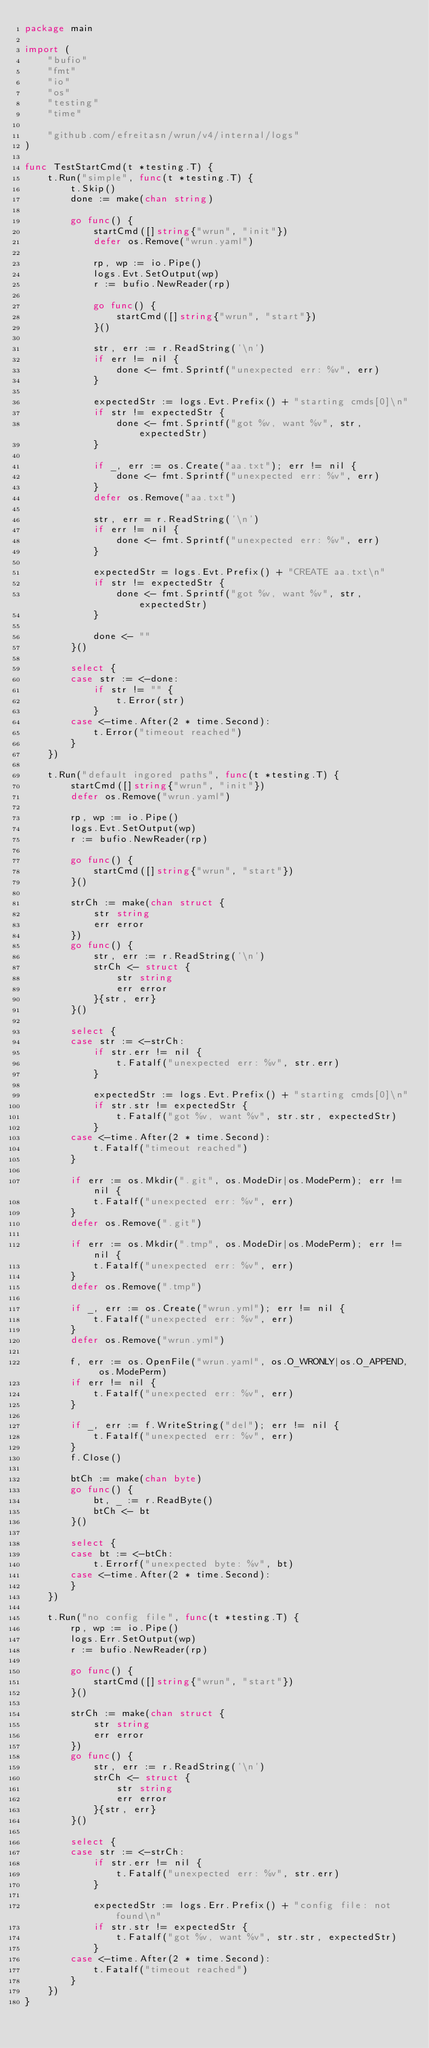<code> <loc_0><loc_0><loc_500><loc_500><_Go_>package main

import (
	"bufio"
	"fmt"
	"io"
	"os"
	"testing"
	"time"

	"github.com/efreitasn/wrun/v4/internal/logs"
)

func TestStartCmd(t *testing.T) {
	t.Run("simple", func(t *testing.T) {
		t.Skip()
		done := make(chan string)

		go func() {
			startCmd([]string{"wrun", "init"})
			defer os.Remove("wrun.yaml")

			rp, wp := io.Pipe()
			logs.Evt.SetOutput(wp)
			r := bufio.NewReader(rp)

			go func() {
				startCmd([]string{"wrun", "start"})
			}()

			str, err := r.ReadString('\n')
			if err != nil {
				done <- fmt.Sprintf("unexpected err: %v", err)
			}

			expectedStr := logs.Evt.Prefix() + "starting cmds[0]\n"
			if str != expectedStr {
				done <- fmt.Sprintf("got %v, want %v", str, expectedStr)
			}

			if _, err := os.Create("aa.txt"); err != nil {
				done <- fmt.Sprintf("unexpected err: %v", err)
			}
			defer os.Remove("aa.txt")

			str, err = r.ReadString('\n')
			if err != nil {
				done <- fmt.Sprintf("unexpected err: %v", err)
			}

			expectedStr = logs.Evt.Prefix() + "CREATE aa.txt\n"
			if str != expectedStr {
				done <- fmt.Sprintf("got %v, want %v", str, expectedStr)
			}

			done <- ""
		}()

		select {
		case str := <-done:
			if str != "" {
				t.Error(str)
			}
		case <-time.After(2 * time.Second):
			t.Error("timeout reached")
		}
	})

	t.Run("default ingored paths", func(t *testing.T) {
		startCmd([]string{"wrun", "init"})
		defer os.Remove("wrun.yaml")

		rp, wp := io.Pipe()
		logs.Evt.SetOutput(wp)
		r := bufio.NewReader(rp)

		go func() {
			startCmd([]string{"wrun", "start"})
		}()

		strCh := make(chan struct {
			str string
			err error
		})
		go func() {
			str, err := r.ReadString('\n')
			strCh <- struct {
				str string
				err error
			}{str, err}
		}()

		select {
		case str := <-strCh:
			if str.err != nil {
				t.Fatalf("unexpected err: %v", str.err)
			}

			expectedStr := logs.Evt.Prefix() + "starting cmds[0]\n"
			if str.str != expectedStr {
				t.Fatalf("got %v, want %v", str.str, expectedStr)
			}
		case <-time.After(2 * time.Second):
			t.Fatalf("timeout reached")
		}

		if err := os.Mkdir(".git", os.ModeDir|os.ModePerm); err != nil {
			t.Fatalf("unexpected err: %v", err)
		}
		defer os.Remove(".git")

		if err := os.Mkdir(".tmp", os.ModeDir|os.ModePerm); err != nil {
			t.Fatalf("unexpected err: %v", err)
		}
		defer os.Remove(".tmp")

		if _, err := os.Create("wrun.yml"); err != nil {
			t.Fatalf("unexpected err: %v", err)
		}
		defer os.Remove("wrun.yml")

		f, err := os.OpenFile("wrun.yaml", os.O_WRONLY|os.O_APPEND, os.ModePerm)
		if err != nil {
			t.Fatalf("unexpected err: %v", err)
		}

		if _, err := f.WriteString("del"); err != nil {
			t.Fatalf("unexpected err: %v", err)
		}
		f.Close()

		btCh := make(chan byte)
		go func() {
			bt, _ := r.ReadByte()
			btCh <- bt
		}()

		select {
		case bt := <-btCh:
			t.Errorf("unexpected byte: %v", bt)
		case <-time.After(2 * time.Second):
		}
	})

	t.Run("no config file", func(t *testing.T) {
		rp, wp := io.Pipe()
		logs.Err.SetOutput(wp)
		r := bufio.NewReader(rp)

		go func() {
			startCmd([]string{"wrun", "start"})
		}()

		strCh := make(chan struct {
			str string
			err error
		})
		go func() {
			str, err := r.ReadString('\n')
			strCh <- struct {
				str string
				err error
			}{str, err}
		}()

		select {
		case str := <-strCh:
			if str.err != nil {
				t.Fatalf("unexpected err: %v", str.err)
			}

			expectedStr := logs.Err.Prefix() + "config file: not found\n"
			if str.str != expectedStr {
				t.Fatalf("got %v, want %v", str.str, expectedStr)
			}
		case <-time.After(2 * time.Second):
			t.Fatalf("timeout reached")
		}
	})
}
</code> 